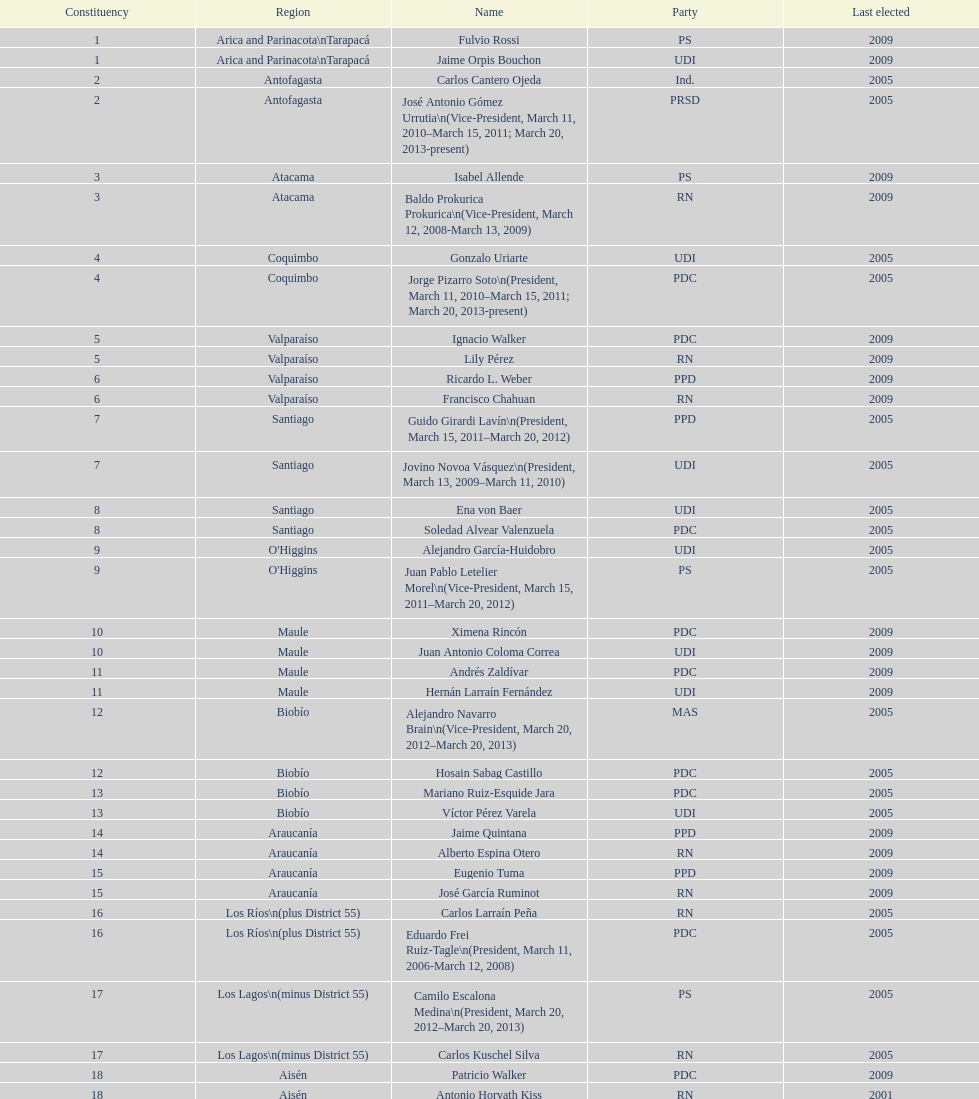Jaime quintana was a member of which party? PPD. Could you parse the entire table? {'header': ['Constituency', 'Region', 'Name', 'Party', 'Last elected'], 'rows': [['1', 'Arica and Parinacota\\nTarapacá', 'Fulvio Rossi', 'PS', '2009'], ['1', 'Arica and Parinacota\\nTarapacá', 'Jaime Orpis Bouchon', 'UDI', '2009'], ['2', 'Antofagasta', 'Carlos Cantero Ojeda', 'Ind.', '2005'], ['2', 'Antofagasta', 'José Antonio Gómez Urrutia\\n(Vice-President, March 11, 2010–March 15, 2011; March 20, 2013-present)', 'PRSD', '2005'], ['3', 'Atacama', 'Isabel Allende', 'PS', '2009'], ['3', 'Atacama', 'Baldo Prokurica Prokurica\\n(Vice-President, March 12, 2008-March 13, 2009)', 'RN', '2009'], ['4', 'Coquimbo', 'Gonzalo Uriarte', 'UDI', '2005'], ['4', 'Coquimbo', 'Jorge Pizarro Soto\\n(President, March 11, 2010–March 15, 2011; March 20, 2013-present)', 'PDC', '2005'], ['5', 'Valparaíso', 'Ignacio Walker', 'PDC', '2009'], ['5', 'Valparaíso', 'Lily Pérez', 'RN', '2009'], ['6', 'Valparaíso', 'Ricardo L. Weber', 'PPD', '2009'], ['6', 'Valparaíso', 'Francisco Chahuan', 'RN', '2009'], ['7', 'Santiago', 'Guido Girardi Lavín\\n(President, March 15, 2011–March 20, 2012)', 'PPD', '2005'], ['7', 'Santiago', 'Jovino Novoa Vásquez\\n(President, March 13, 2009–March 11, 2010)', 'UDI', '2005'], ['8', 'Santiago', 'Ena von Baer', 'UDI', '2005'], ['8', 'Santiago', 'Soledad Alvear Valenzuela', 'PDC', '2005'], ['9', "O'Higgins", 'Alejandro García-Huidobro', 'UDI', '2005'], ['9', "O'Higgins", 'Juan Pablo Letelier Morel\\n(Vice-President, March 15, 2011–March 20, 2012)', 'PS', '2005'], ['10', 'Maule', 'Ximena Rincón', 'PDC', '2009'], ['10', 'Maule', 'Juan Antonio Coloma Correa', 'UDI', '2009'], ['11', 'Maule', 'Andrés Zaldívar', 'PDC', '2009'], ['11', 'Maule', 'Hernán Larraín Fernández', 'UDI', '2009'], ['12', 'Biobío', 'Alejandro Navarro Brain\\n(Vice-President, March 20, 2012–March 20, 2013)', 'MAS', '2005'], ['12', 'Biobío', 'Hosain Sabag Castillo', 'PDC', '2005'], ['13', 'Biobío', 'Mariano Ruiz-Esquide Jara', 'PDC', '2005'], ['13', 'Biobío', 'Víctor Pérez Varela', 'UDI', '2005'], ['14', 'Araucanía', 'Jaime Quintana', 'PPD', '2009'], ['14', 'Araucanía', 'Alberto Espina Otero', 'RN', '2009'], ['15', 'Araucanía', 'Eugenio Tuma', 'PPD', '2009'], ['15', 'Araucanía', 'José García Ruminot', 'RN', '2009'], ['16', 'Los Ríos\\n(plus District 55)', 'Carlos Larraín Peña', 'RN', '2005'], ['16', 'Los Ríos\\n(plus District 55)', 'Eduardo Frei Ruiz-Tagle\\n(President, March 11, 2006-March 12, 2008)', 'PDC', '2005'], ['17', 'Los Lagos\\n(minus District 55)', 'Camilo Escalona Medina\\n(President, March 20, 2012–March 20, 2013)', 'PS', '2005'], ['17', 'Los Lagos\\n(minus District 55)', 'Carlos Kuschel Silva', 'RN', '2005'], ['18', 'Aisén', 'Patricio Walker', 'PDC', '2009'], ['18', 'Aisén', 'Antonio Horvath Kiss', 'RN', '2001'], ['19', 'Magallanes', 'Carlos Bianchi Chelech\\n(Vice-President, March 13, 2009–March 11, 2010)', 'Ind.', '2005'], ['19', 'Magallanes', 'Pedro Muñoz Aburto', 'PS', '2005']]} 